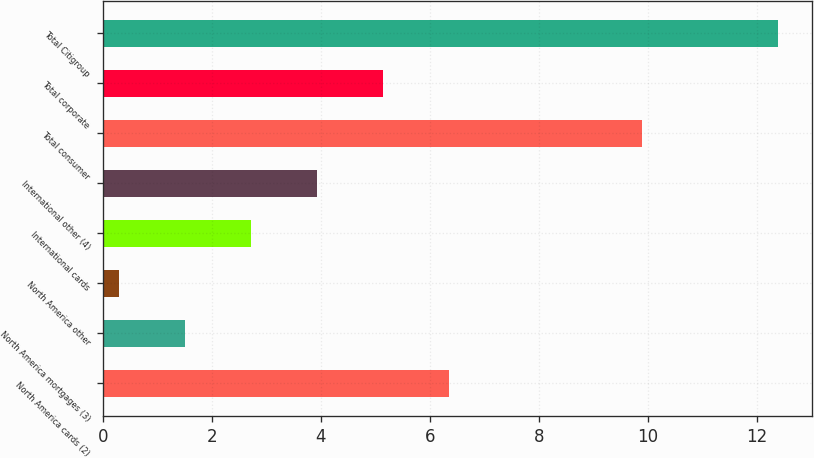Convert chart. <chart><loc_0><loc_0><loc_500><loc_500><bar_chart><fcel>North America cards (2)<fcel>North America mortgages (3)<fcel>North America other<fcel>International cards<fcel>International other (4)<fcel>Total consumer<fcel>Total corporate<fcel>Total Citigroup<nl><fcel>6.35<fcel>1.51<fcel>0.3<fcel>2.72<fcel>3.93<fcel>9.9<fcel>5.14<fcel>12.4<nl></chart> 